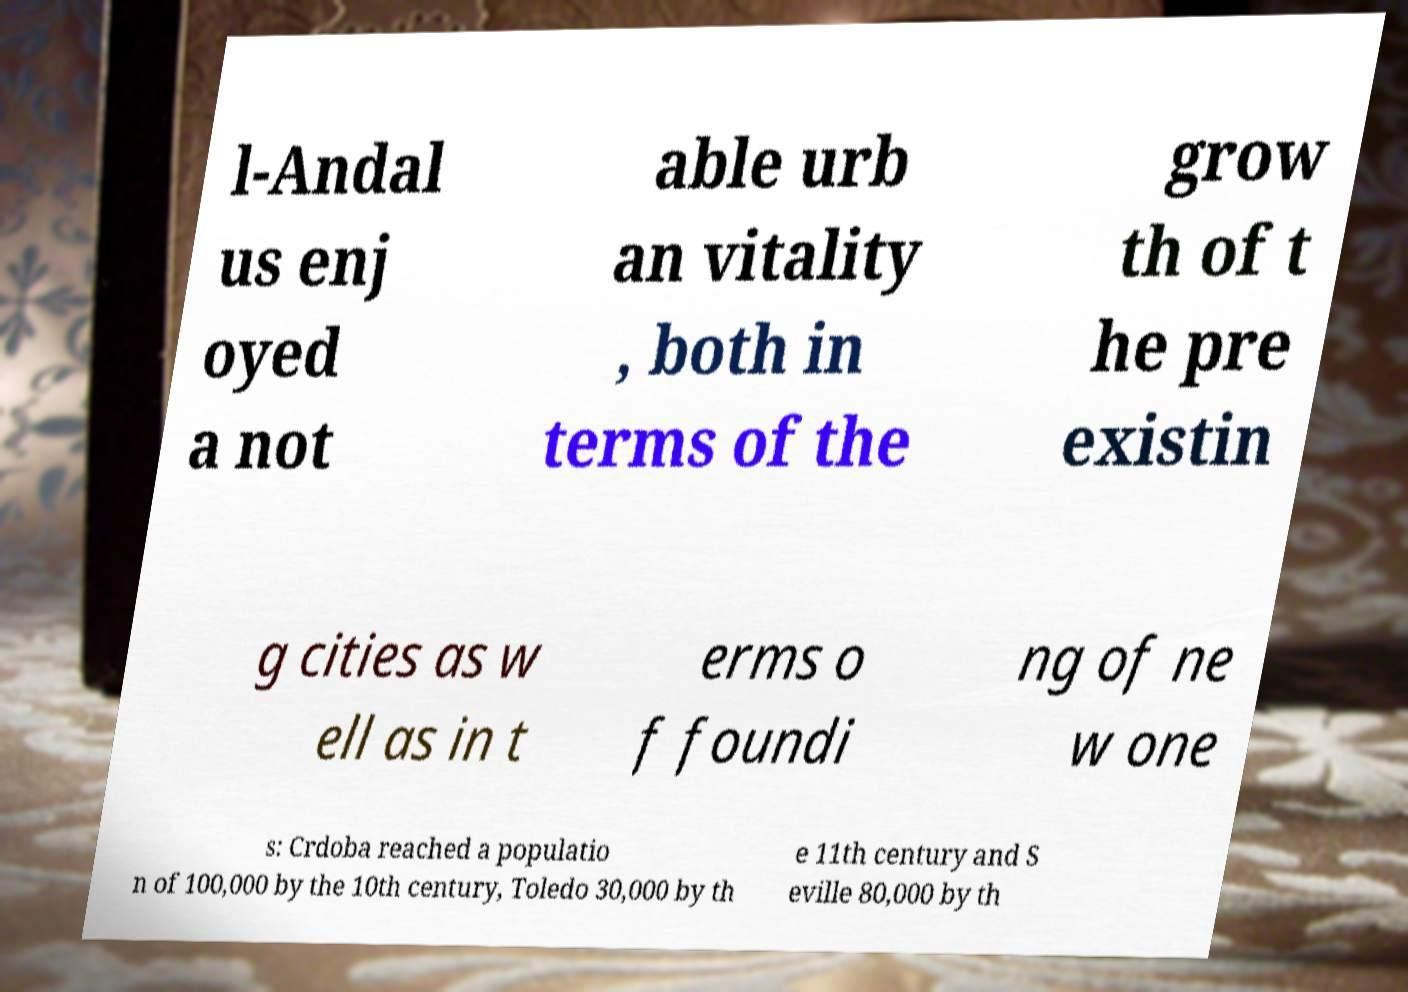What messages or text are displayed in this image? I need them in a readable, typed format. l-Andal us enj oyed a not able urb an vitality , both in terms of the grow th of t he pre existin g cities as w ell as in t erms o f foundi ng of ne w one s: Crdoba reached a populatio n of 100,000 by the 10th century, Toledo 30,000 by th e 11th century and S eville 80,000 by th 